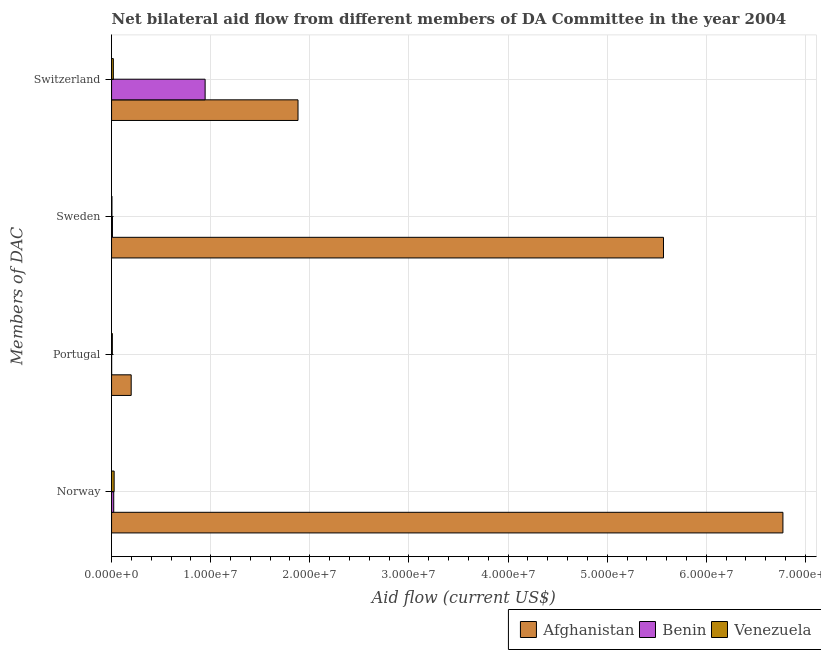Are the number of bars per tick equal to the number of legend labels?
Your answer should be compact. Yes. Are the number of bars on each tick of the Y-axis equal?
Give a very brief answer. Yes. What is the label of the 1st group of bars from the top?
Offer a terse response. Switzerland. What is the amount of aid given by switzerland in Afghanistan?
Keep it short and to the point. 1.88e+07. Across all countries, what is the maximum amount of aid given by portugal?
Your answer should be very brief. 1.98e+06. Across all countries, what is the minimum amount of aid given by norway?
Keep it short and to the point. 2.20e+05. In which country was the amount of aid given by switzerland maximum?
Provide a succinct answer. Afghanistan. In which country was the amount of aid given by portugal minimum?
Your response must be concise. Benin. What is the total amount of aid given by switzerland in the graph?
Your response must be concise. 2.84e+07. What is the difference between the amount of aid given by portugal in Venezuela and that in Afghanistan?
Your response must be concise. -1.90e+06. What is the difference between the amount of aid given by norway in Afghanistan and the amount of aid given by switzerland in Venezuela?
Offer a terse response. 6.76e+07. What is the average amount of aid given by switzerland per country?
Provide a succinct answer. 9.48e+06. What is the difference between the amount of aid given by sweden and amount of aid given by norway in Benin?
Provide a succinct answer. -1.30e+05. In how many countries, is the amount of aid given by switzerland greater than 24000000 US$?
Provide a succinct answer. 0. What is the ratio of the amount of aid given by sweden in Benin to that in Afghanistan?
Keep it short and to the point. 0. Is the amount of aid given by portugal in Venezuela less than that in Benin?
Keep it short and to the point. No. Is the difference between the amount of aid given by switzerland in Benin and Afghanistan greater than the difference between the amount of aid given by sweden in Benin and Afghanistan?
Your response must be concise. Yes. What is the difference between the highest and the second highest amount of aid given by norway?
Provide a succinct answer. 6.75e+07. What is the difference between the highest and the lowest amount of aid given by portugal?
Provide a short and direct response. 1.97e+06. In how many countries, is the amount of aid given by sweden greater than the average amount of aid given by sweden taken over all countries?
Provide a succinct answer. 1. Is it the case that in every country, the sum of the amount of aid given by portugal and amount of aid given by norway is greater than the sum of amount of aid given by switzerland and amount of aid given by sweden?
Offer a very short reply. No. What does the 1st bar from the top in Switzerland represents?
Offer a terse response. Venezuela. What does the 1st bar from the bottom in Sweden represents?
Offer a very short reply. Afghanistan. How many countries are there in the graph?
Give a very brief answer. 3. What is the difference between two consecutive major ticks on the X-axis?
Keep it short and to the point. 1.00e+07. How are the legend labels stacked?
Your answer should be compact. Horizontal. What is the title of the graph?
Keep it short and to the point. Net bilateral aid flow from different members of DA Committee in the year 2004. What is the label or title of the X-axis?
Your response must be concise. Aid flow (current US$). What is the label or title of the Y-axis?
Ensure brevity in your answer.  Members of DAC. What is the Aid flow (current US$) of Afghanistan in Norway?
Provide a short and direct response. 6.77e+07. What is the Aid flow (current US$) in Benin in Norway?
Your response must be concise. 2.20e+05. What is the Aid flow (current US$) in Afghanistan in Portugal?
Give a very brief answer. 1.98e+06. What is the Aid flow (current US$) in Benin in Portugal?
Provide a succinct answer. 10000. What is the Aid flow (current US$) in Venezuela in Portugal?
Your response must be concise. 8.00e+04. What is the Aid flow (current US$) in Afghanistan in Sweden?
Keep it short and to the point. 5.57e+07. What is the Aid flow (current US$) of Benin in Sweden?
Offer a very short reply. 9.00e+04. What is the Aid flow (current US$) in Afghanistan in Switzerland?
Ensure brevity in your answer.  1.88e+07. What is the Aid flow (current US$) of Benin in Switzerland?
Ensure brevity in your answer.  9.44e+06. What is the Aid flow (current US$) of Venezuela in Switzerland?
Your answer should be very brief. 1.80e+05. Across all Members of DAC, what is the maximum Aid flow (current US$) in Afghanistan?
Your answer should be very brief. 6.77e+07. Across all Members of DAC, what is the maximum Aid flow (current US$) of Benin?
Give a very brief answer. 9.44e+06. Across all Members of DAC, what is the minimum Aid flow (current US$) in Afghanistan?
Provide a short and direct response. 1.98e+06. Across all Members of DAC, what is the minimum Aid flow (current US$) of Venezuela?
Keep it short and to the point. 4.00e+04. What is the total Aid flow (current US$) in Afghanistan in the graph?
Make the answer very short. 1.44e+08. What is the total Aid flow (current US$) of Benin in the graph?
Your response must be concise. 9.76e+06. What is the total Aid flow (current US$) in Venezuela in the graph?
Keep it short and to the point. 5.60e+05. What is the difference between the Aid flow (current US$) in Afghanistan in Norway and that in Portugal?
Provide a short and direct response. 6.58e+07. What is the difference between the Aid flow (current US$) in Afghanistan in Norway and that in Sweden?
Your answer should be compact. 1.20e+07. What is the difference between the Aid flow (current US$) of Benin in Norway and that in Sweden?
Provide a short and direct response. 1.30e+05. What is the difference between the Aid flow (current US$) of Afghanistan in Norway and that in Switzerland?
Offer a very short reply. 4.89e+07. What is the difference between the Aid flow (current US$) of Benin in Norway and that in Switzerland?
Your response must be concise. -9.22e+06. What is the difference between the Aid flow (current US$) in Afghanistan in Portugal and that in Sweden?
Give a very brief answer. -5.37e+07. What is the difference between the Aid flow (current US$) in Benin in Portugal and that in Sweden?
Make the answer very short. -8.00e+04. What is the difference between the Aid flow (current US$) of Venezuela in Portugal and that in Sweden?
Make the answer very short. 4.00e+04. What is the difference between the Aid flow (current US$) in Afghanistan in Portugal and that in Switzerland?
Your answer should be compact. -1.68e+07. What is the difference between the Aid flow (current US$) in Benin in Portugal and that in Switzerland?
Provide a succinct answer. -9.43e+06. What is the difference between the Aid flow (current US$) in Afghanistan in Sweden and that in Switzerland?
Offer a terse response. 3.69e+07. What is the difference between the Aid flow (current US$) in Benin in Sweden and that in Switzerland?
Offer a very short reply. -9.35e+06. What is the difference between the Aid flow (current US$) in Venezuela in Sweden and that in Switzerland?
Ensure brevity in your answer.  -1.40e+05. What is the difference between the Aid flow (current US$) in Afghanistan in Norway and the Aid flow (current US$) in Benin in Portugal?
Ensure brevity in your answer.  6.77e+07. What is the difference between the Aid flow (current US$) of Afghanistan in Norway and the Aid flow (current US$) of Venezuela in Portugal?
Make the answer very short. 6.76e+07. What is the difference between the Aid flow (current US$) of Benin in Norway and the Aid flow (current US$) of Venezuela in Portugal?
Make the answer very short. 1.40e+05. What is the difference between the Aid flow (current US$) in Afghanistan in Norway and the Aid flow (current US$) in Benin in Sweden?
Provide a succinct answer. 6.76e+07. What is the difference between the Aid flow (current US$) in Afghanistan in Norway and the Aid flow (current US$) in Venezuela in Sweden?
Offer a very short reply. 6.77e+07. What is the difference between the Aid flow (current US$) in Afghanistan in Norway and the Aid flow (current US$) in Benin in Switzerland?
Your response must be concise. 5.83e+07. What is the difference between the Aid flow (current US$) in Afghanistan in Norway and the Aid flow (current US$) in Venezuela in Switzerland?
Your answer should be very brief. 6.76e+07. What is the difference between the Aid flow (current US$) in Benin in Norway and the Aid flow (current US$) in Venezuela in Switzerland?
Your answer should be compact. 4.00e+04. What is the difference between the Aid flow (current US$) in Afghanistan in Portugal and the Aid flow (current US$) in Benin in Sweden?
Offer a terse response. 1.89e+06. What is the difference between the Aid flow (current US$) of Afghanistan in Portugal and the Aid flow (current US$) of Venezuela in Sweden?
Offer a very short reply. 1.94e+06. What is the difference between the Aid flow (current US$) of Benin in Portugal and the Aid flow (current US$) of Venezuela in Sweden?
Your answer should be compact. -3.00e+04. What is the difference between the Aid flow (current US$) of Afghanistan in Portugal and the Aid flow (current US$) of Benin in Switzerland?
Ensure brevity in your answer.  -7.46e+06. What is the difference between the Aid flow (current US$) of Afghanistan in Portugal and the Aid flow (current US$) of Venezuela in Switzerland?
Your answer should be very brief. 1.80e+06. What is the difference between the Aid flow (current US$) of Benin in Portugal and the Aid flow (current US$) of Venezuela in Switzerland?
Give a very brief answer. -1.70e+05. What is the difference between the Aid flow (current US$) of Afghanistan in Sweden and the Aid flow (current US$) of Benin in Switzerland?
Your answer should be compact. 4.62e+07. What is the difference between the Aid flow (current US$) of Afghanistan in Sweden and the Aid flow (current US$) of Venezuela in Switzerland?
Offer a very short reply. 5.55e+07. What is the difference between the Aid flow (current US$) in Benin in Sweden and the Aid flow (current US$) in Venezuela in Switzerland?
Your answer should be very brief. -9.00e+04. What is the average Aid flow (current US$) in Afghanistan per Members of DAC?
Give a very brief answer. 3.60e+07. What is the average Aid flow (current US$) in Benin per Members of DAC?
Give a very brief answer. 2.44e+06. What is the average Aid flow (current US$) of Venezuela per Members of DAC?
Provide a short and direct response. 1.40e+05. What is the difference between the Aid flow (current US$) of Afghanistan and Aid flow (current US$) of Benin in Norway?
Make the answer very short. 6.75e+07. What is the difference between the Aid flow (current US$) in Afghanistan and Aid flow (current US$) in Venezuela in Norway?
Provide a short and direct response. 6.75e+07. What is the difference between the Aid flow (current US$) of Afghanistan and Aid flow (current US$) of Benin in Portugal?
Provide a succinct answer. 1.97e+06. What is the difference between the Aid flow (current US$) in Afghanistan and Aid flow (current US$) in Venezuela in Portugal?
Ensure brevity in your answer.  1.90e+06. What is the difference between the Aid flow (current US$) in Benin and Aid flow (current US$) in Venezuela in Portugal?
Your response must be concise. -7.00e+04. What is the difference between the Aid flow (current US$) in Afghanistan and Aid flow (current US$) in Benin in Sweden?
Provide a short and direct response. 5.56e+07. What is the difference between the Aid flow (current US$) in Afghanistan and Aid flow (current US$) in Venezuela in Sweden?
Keep it short and to the point. 5.56e+07. What is the difference between the Aid flow (current US$) of Afghanistan and Aid flow (current US$) of Benin in Switzerland?
Your answer should be compact. 9.37e+06. What is the difference between the Aid flow (current US$) of Afghanistan and Aid flow (current US$) of Venezuela in Switzerland?
Ensure brevity in your answer.  1.86e+07. What is the difference between the Aid flow (current US$) in Benin and Aid flow (current US$) in Venezuela in Switzerland?
Keep it short and to the point. 9.26e+06. What is the ratio of the Aid flow (current US$) in Afghanistan in Norway to that in Portugal?
Make the answer very short. 34.21. What is the ratio of the Aid flow (current US$) of Benin in Norway to that in Portugal?
Offer a terse response. 22. What is the ratio of the Aid flow (current US$) in Venezuela in Norway to that in Portugal?
Offer a terse response. 3.25. What is the ratio of the Aid flow (current US$) in Afghanistan in Norway to that in Sweden?
Offer a terse response. 1.22. What is the ratio of the Aid flow (current US$) of Benin in Norway to that in Sweden?
Make the answer very short. 2.44. What is the ratio of the Aid flow (current US$) of Venezuela in Norway to that in Sweden?
Provide a succinct answer. 6.5. What is the ratio of the Aid flow (current US$) of Afghanistan in Norway to that in Switzerland?
Keep it short and to the point. 3.6. What is the ratio of the Aid flow (current US$) of Benin in Norway to that in Switzerland?
Ensure brevity in your answer.  0.02. What is the ratio of the Aid flow (current US$) of Venezuela in Norway to that in Switzerland?
Ensure brevity in your answer.  1.44. What is the ratio of the Aid flow (current US$) of Afghanistan in Portugal to that in Sweden?
Your answer should be very brief. 0.04. What is the ratio of the Aid flow (current US$) in Benin in Portugal to that in Sweden?
Ensure brevity in your answer.  0.11. What is the ratio of the Aid flow (current US$) in Afghanistan in Portugal to that in Switzerland?
Make the answer very short. 0.11. What is the ratio of the Aid flow (current US$) in Benin in Portugal to that in Switzerland?
Keep it short and to the point. 0. What is the ratio of the Aid flow (current US$) in Venezuela in Portugal to that in Switzerland?
Provide a short and direct response. 0.44. What is the ratio of the Aid flow (current US$) in Afghanistan in Sweden to that in Switzerland?
Give a very brief answer. 2.96. What is the ratio of the Aid flow (current US$) in Benin in Sweden to that in Switzerland?
Ensure brevity in your answer.  0.01. What is the ratio of the Aid flow (current US$) of Venezuela in Sweden to that in Switzerland?
Your answer should be compact. 0.22. What is the difference between the highest and the second highest Aid flow (current US$) in Afghanistan?
Provide a succinct answer. 1.20e+07. What is the difference between the highest and the second highest Aid flow (current US$) of Benin?
Offer a very short reply. 9.22e+06. What is the difference between the highest and the lowest Aid flow (current US$) in Afghanistan?
Your answer should be very brief. 6.58e+07. What is the difference between the highest and the lowest Aid flow (current US$) in Benin?
Your answer should be very brief. 9.43e+06. What is the difference between the highest and the lowest Aid flow (current US$) in Venezuela?
Your answer should be very brief. 2.20e+05. 